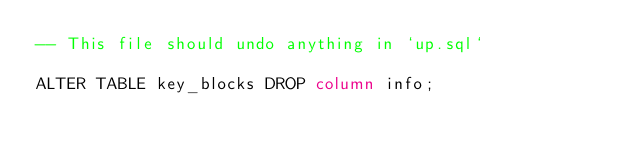<code> <loc_0><loc_0><loc_500><loc_500><_SQL_>-- This file should undo anything in `up.sql`

ALTER TABLE key_blocks DROP column info;
</code> 